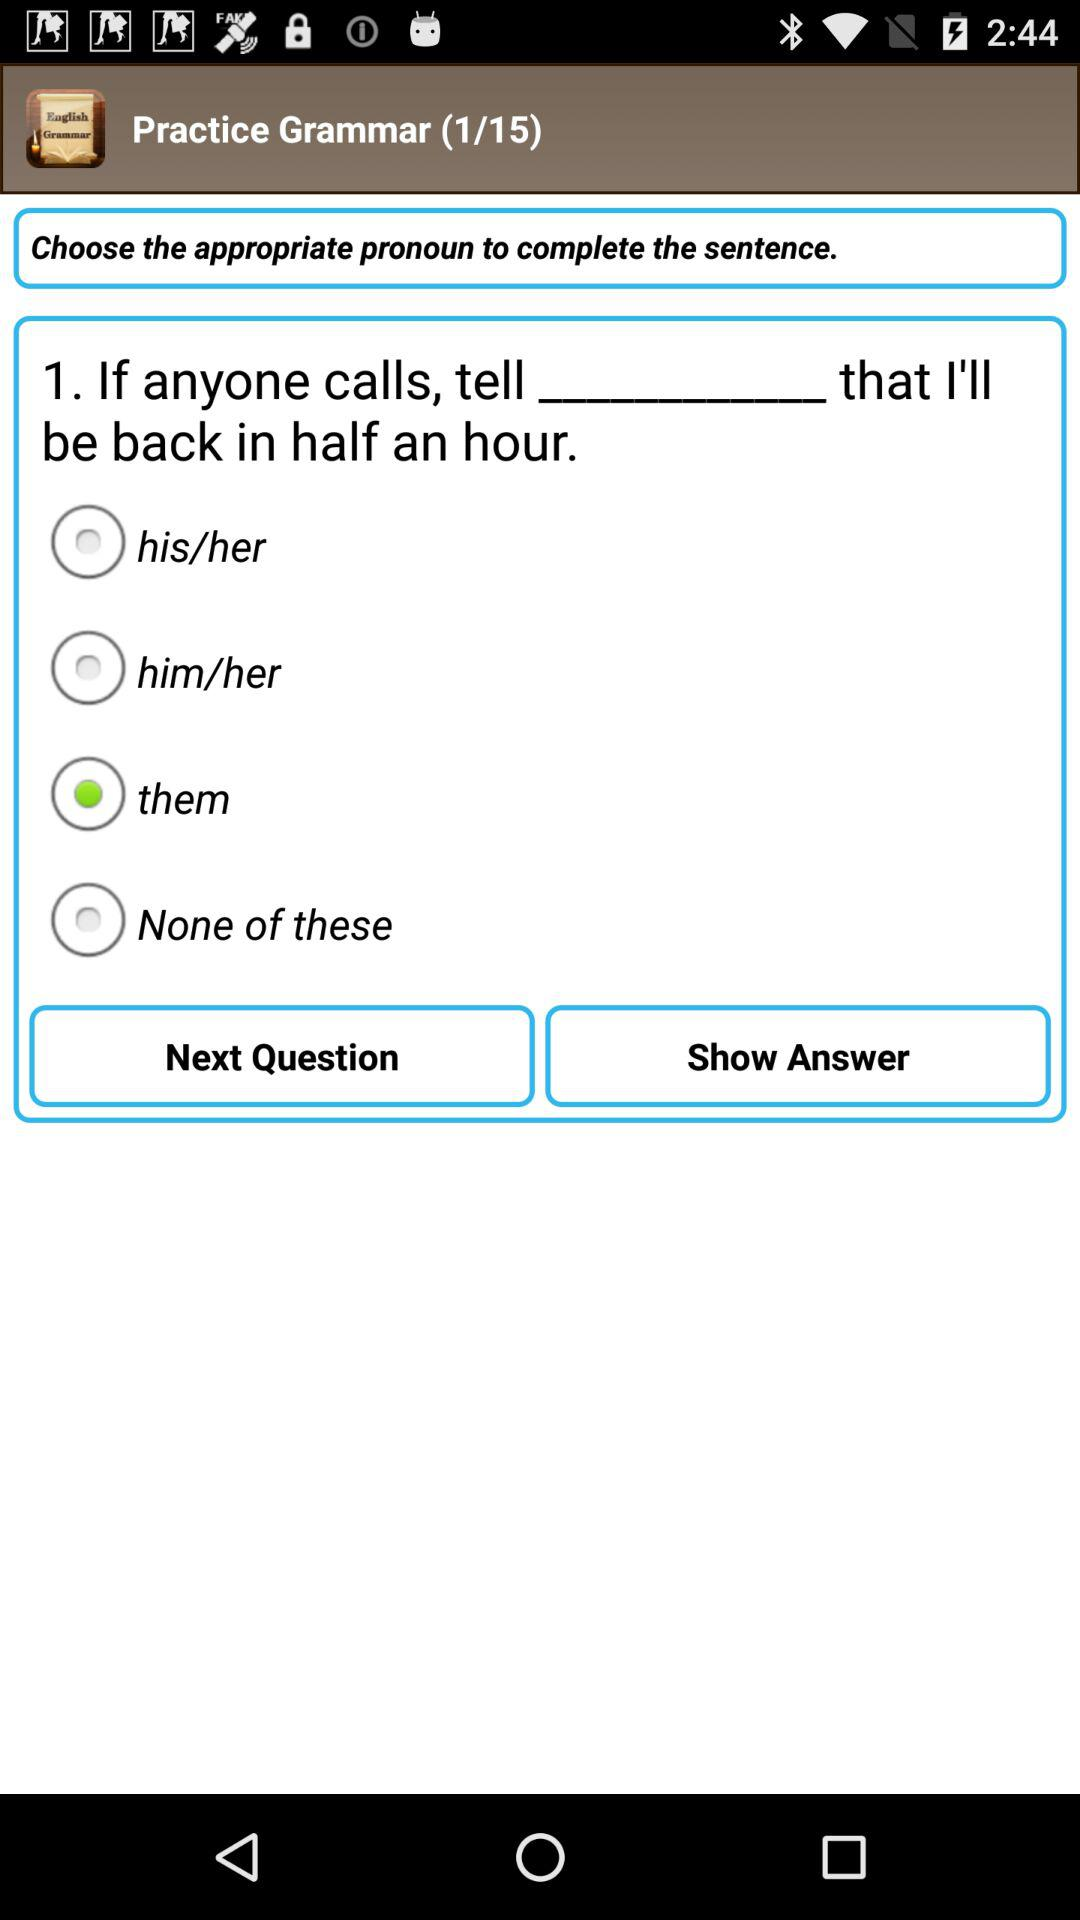How many questions are there? There are 15 questions. 